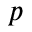Convert formula to latex. <formula><loc_0><loc_0><loc_500><loc_500>p</formula> 